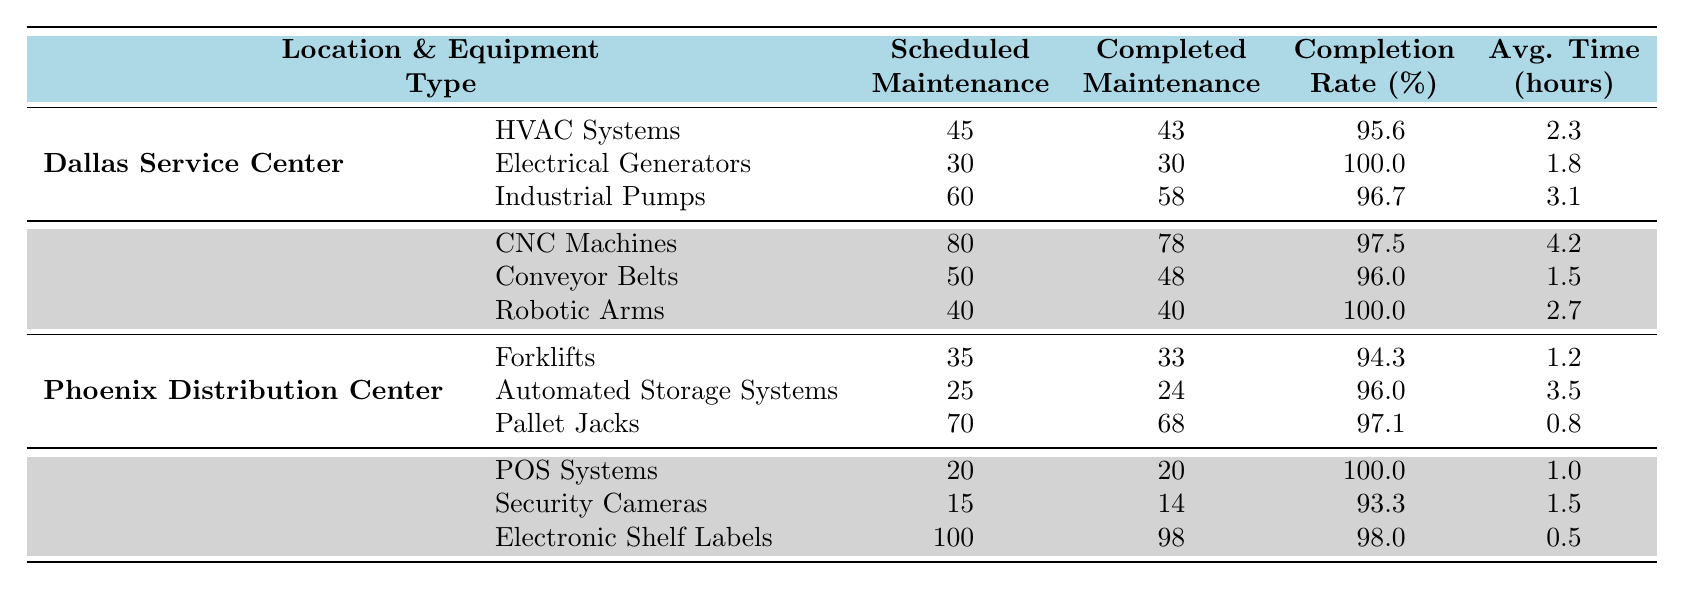What is the completion rate for HVAC Systems in Dallas? The completion rate for HVAC Systems in Dallas is directly given in the table. It states 95.6%.
Answer: 95.6% How many total pieces of equipment were scheduled for maintenance across all locations? To find the total scheduled maintenance, sum the scheduled maintenance for each equipment type across all locations: 45 + 30 + 60 + 80 + 50 + 40 + 35 + 25 + 70 + 20 + 15 + 100 = 550.
Answer: 550 Which location has the highest completion rate for its equipment? Compare the completion rates: Dallas has a max of 100%, Houston also has 100% for Robotic Arms, Chicago has 100% for POS Systems, and others are lower. Thus, there are three locations with the highest completion rate of 100%.
Answer: Multiple locations (Houston, Chicago) What is the average time per service for Industrial Pumps in Dallas? According to the table, the average time per service for Industrial Pumps in Dallas is given directly as 3.1 hours.
Answer: 3.1 hours What is the difference in completion rates between CNC Machines and Conveyor Belts in Houston? The completion rates for CNC Machines and Conveyor Belts in Houston are 97.5% and 96%, respectively. The difference is calculated as 97.5 - 96 = 1.5%.
Answer: 1.5% How many completed maintenance tasks were there for Automated Storage Systems in Phoenix? The table shows that for Automated Storage Systems in Phoenix, 24 maintenance tasks were completed.
Answer: 24 True or False: The average time per service for Electrical Generators is less than 2 hours. The average time per service is noted in the table as 1.8 hours for Electrical Generators, which is indeed less than 2 hours, making the statement true.
Answer: True What is the average completion rate across all equipment types at the Dallas Service Center? The completion rates for Dallas are 95.6%, 100%, and 96.7%. The average is calculated as (95.6 + 100 + 96.7) / 3 = 97.433, approximately 97.4%.
Answer: 97.4% Which equipment type has the lowest completion rate in Chicago? In Chicago, the completion rates are 100% for POS Systems, 93.3% for Security Cameras, and 98% for Electronic Shelf Labels. The lowest rate is for Security Cameras at 93.3%.
Answer: Security Cameras How many total completed maintenance tasks were recorded for Electric Generators and HVAC Systems in Dallas? For Electric Generators in Dallas, 30 were completed and for HVAC Systems, 43 were completed. Summing these gives 30 + 43 = 73 completed tasks.
Answer: 73 Which location has the least average time per service based on the data? By reviewing the average times for each location, Dallas averages 2.3, Houston averages 2.7, Phoenix averages 1.2, and Chicago averages 1.0. Therefore, Phoenix has the least average time with 0.8 hours for Pallet Jacks.
Answer: Phoenix 